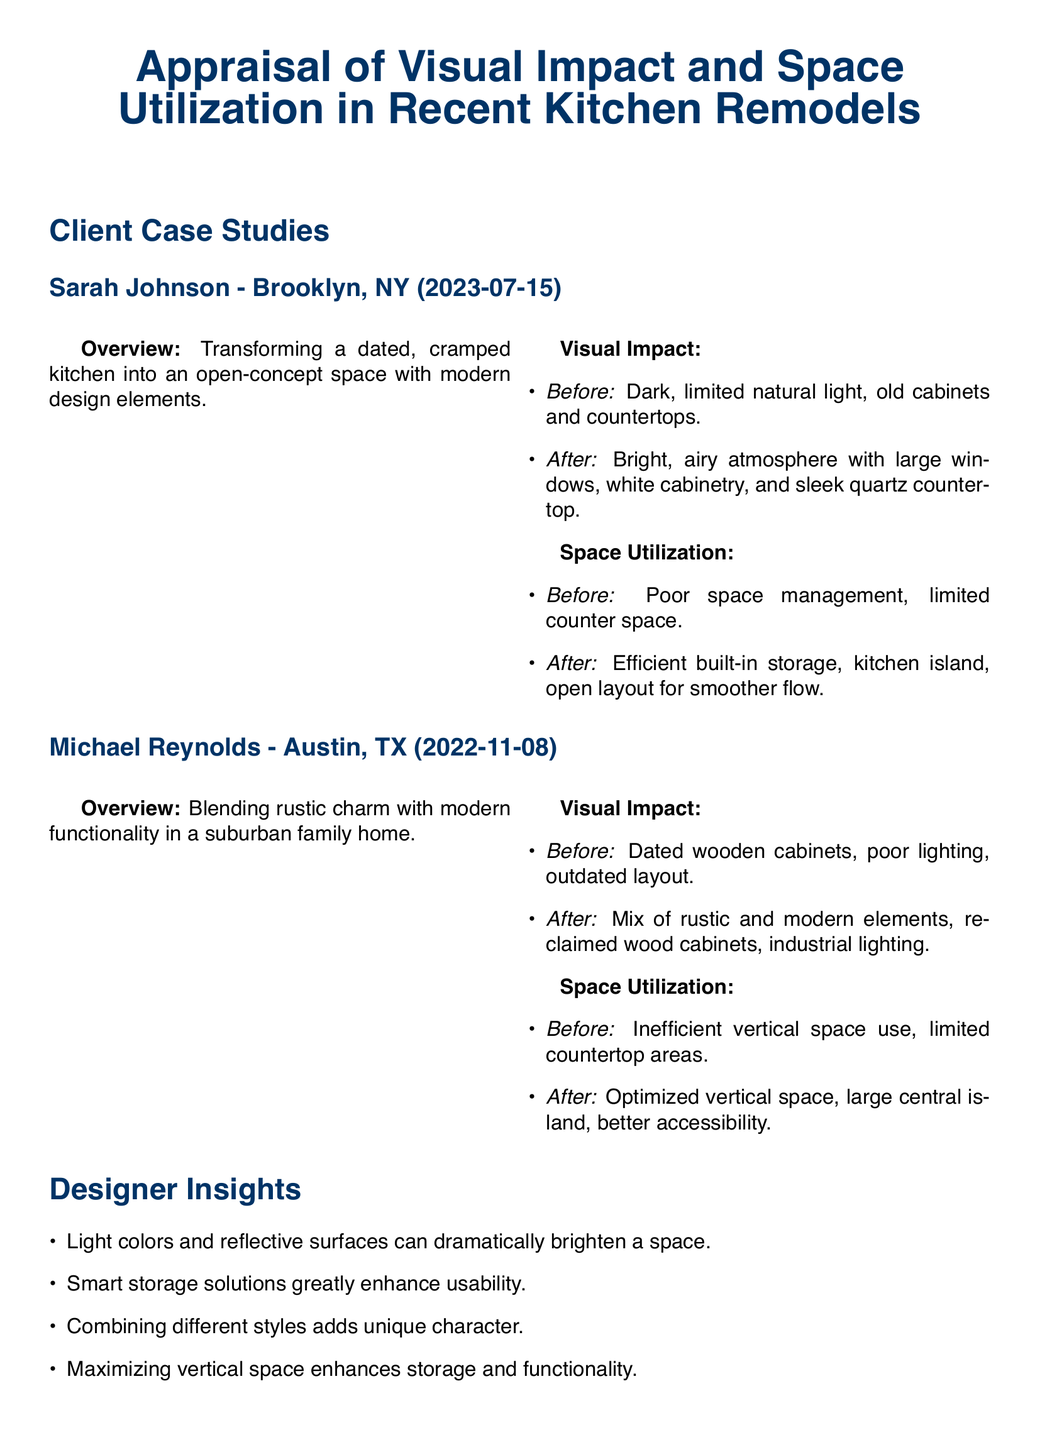What is the date of Sarah Johnson's kitchen remodel? Sarah Johnson's kitchen remodel took place on July 15, 2023.
Answer: July 15, 2023 What type of kitchen design did Sarah Johnson aim for? Sarah Johnson aimed for an open-concept space with modern design elements.
Answer: Open-concept space with modern design elements What was a significant change in the visual impact of Michael Reynolds' kitchen? Michael Reynolds changed to a mix of rustic and modern elements with reclaimed wood cabinets and industrial lighting.
Answer: Mix of rustic and modern elements What did Sarah Johnson implement to improve space utilization? Sarah Johnson added efficient built-in storage, a kitchen island, and an open layout.
Answer: Efficient built-in storage, kitchen island, open layout How many kitchen remodel case studies are presented in the document? The document presents two case studies.
Answer: Two What is one designer insight mentioned about color choice? One designer insight is that light colors and reflective surfaces can dramatically brighten a space.
Answer: Light colors and reflective surfaces What is recommended for improving functional layouts? It is recommended to prioritize functional layouts for easy movement.
Answer: Prioritize functional layouts for easy movement What was a common theme observed in the general observations section? A common theme is that open layouts and light color schemes improve visual impact.
Answer: Open layouts and light color schemes What specific storage solution is highlighted as enhancing usability? Smart storage solutions are highlighted as greatly enhancing usability.
Answer: Smart storage solutions 